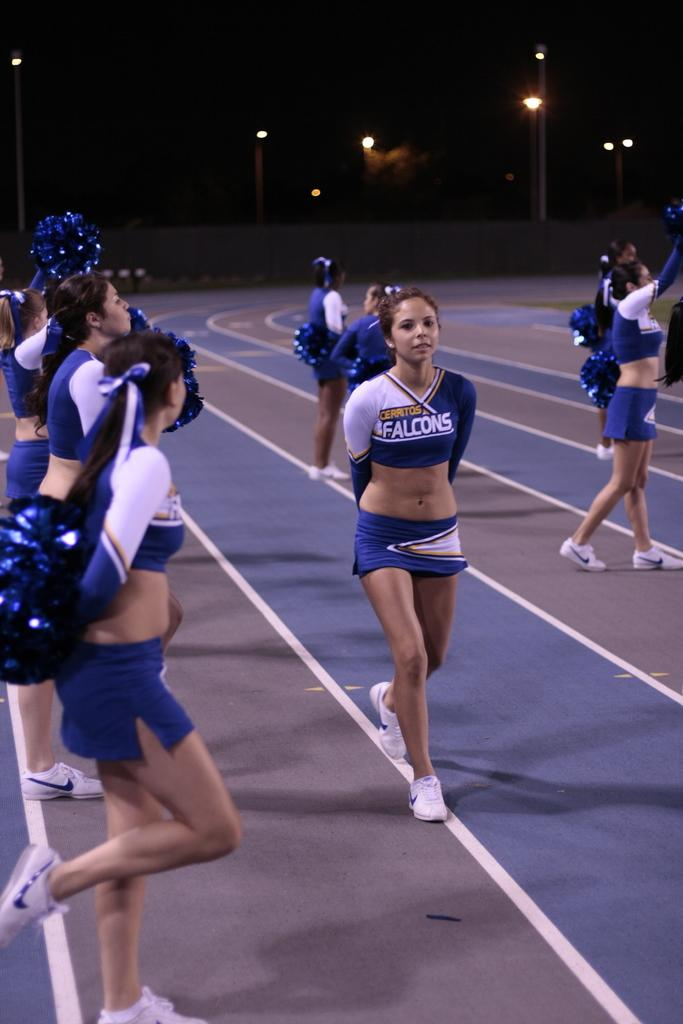<image>
Relay a brief, clear account of the picture shown. A Falcons cheerleader walks in front of the other cheerleaders. 